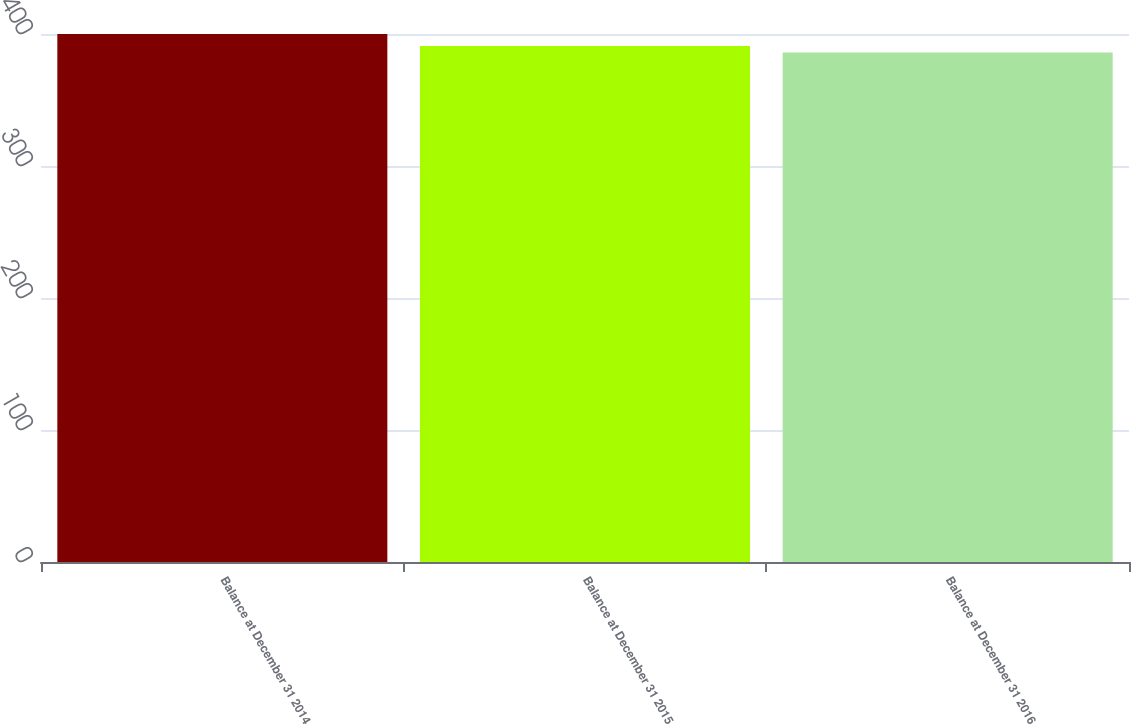<chart> <loc_0><loc_0><loc_500><loc_500><bar_chart><fcel>Balance at December 31 2014<fcel>Balance at December 31 2015<fcel>Balance at December 31 2016<nl><fcel>400<fcel>391<fcel>386<nl></chart> 